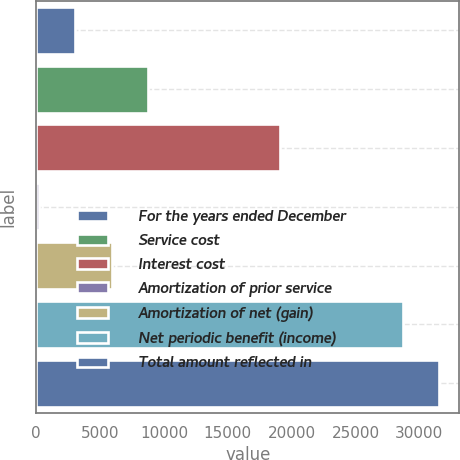<chart> <loc_0><loc_0><loc_500><loc_500><bar_chart><fcel>For the years ended December<fcel>Service cost<fcel>Interest cost<fcel>Amortization of prior service<fcel>Amortization of net (gain)<fcel>Net periodic benefit (income)<fcel>Total amount reflected in<nl><fcel>3053.9<fcel>8777.7<fcel>19083<fcel>192<fcel>5915.8<fcel>28698<fcel>31559.9<nl></chart> 